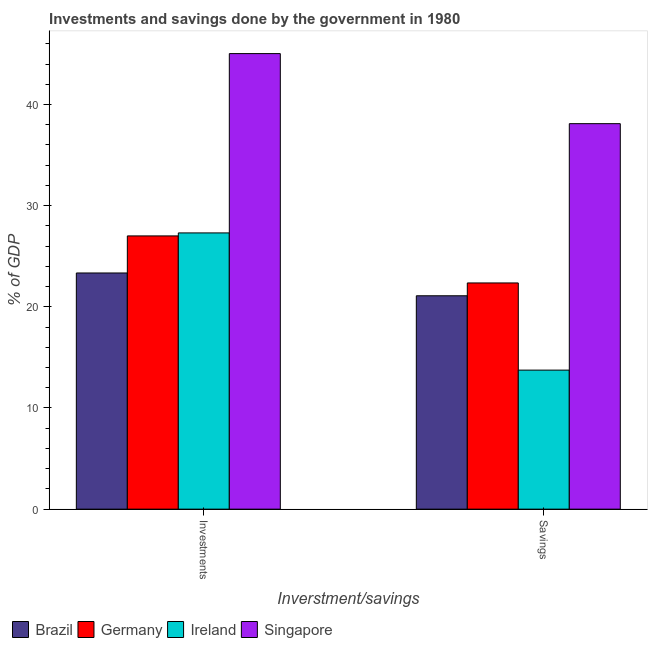How many groups of bars are there?
Offer a terse response. 2. Are the number of bars per tick equal to the number of legend labels?
Make the answer very short. Yes. How many bars are there on the 2nd tick from the left?
Provide a succinct answer. 4. What is the label of the 2nd group of bars from the left?
Offer a very short reply. Savings. What is the investments of government in Singapore?
Keep it short and to the point. 45.03. Across all countries, what is the maximum investments of government?
Your answer should be compact. 45.03. Across all countries, what is the minimum savings of government?
Keep it short and to the point. 13.74. In which country was the investments of government maximum?
Provide a short and direct response. Singapore. In which country was the savings of government minimum?
Offer a very short reply. Ireland. What is the total investments of government in the graph?
Provide a succinct answer. 122.7. What is the difference between the savings of government in Singapore and that in Germany?
Your answer should be very brief. 15.75. What is the difference between the investments of government in Brazil and the savings of government in Ireland?
Keep it short and to the point. 9.6. What is the average savings of government per country?
Make the answer very short. 23.83. What is the difference between the savings of government and investments of government in Singapore?
Provide a short and direct response. -6.93. What is the ratio of the savings of government in Singapore to that in Brazil?
Ensure brevity in your answer.  1.81. Is the investments of government in Brazil less than that in Singapore?
Your answer should be very brief. Yes. What does the 2nd bar from the left in Investments represents?
Your response must be concise. Germany. How many countries are there in the graph?
Offer a terse response. 4. What is the difference between two consecutive major ticks on the Y-axis?
Provide a succinct answer. 10. Where does the legend appear in the graph?
Keep it short and to the point. Bottom left. How many legend labels are there?
Ensure brevity in your answer.  4. What is the title of the graph?
Provide a succinct answer. Investments and savings done by the government in 1980. Does "Cyprus" appear as one of the legend labels in the graph?
Offer a terse response. No. What is the label or title of the X-axis?
Ensure brevity in your answer.  Inverstment/savings. What is the label or title of the Y-axis?
Your answer should be compact. % of GDP. What is the % of GDP in Brazil in Investments?
Give a very brief answer. 23.35. What is the % of GDP of Germany in Investments?
Keep it short and to the point. 27.01. What is the % of GDP in Ireland in Investments?
Offer a very short reply. 27.31. What is the % of GDP in Singapore in Investments?
Your answer should be very brief. 45.03. What is the % of GDP in Brazil in Savings?
Your response must be concise. 21.09. What is the % of GDP of Germany in Savings?
Your answer should be very brief. 22.36. What is the % of GDP in Ireland in Savings?
Your answer should be very brief. 13.74. What is the % of GDP in Singapore in Savings?
Offer a very short reply. 38.11. Across all Inverstment/savings, what is the maximum % of GDP in Brazil?
Your answer should be compact. 23.35. Across all Inverstment/savings, what is the maximum % of GDP in Germany?
Give a very brief answer. 27.01. Across all Inverstment/savings, what is the maximum % of GDP in Ireland?
Offer a very short reply. 27.31. Across all Inverstment/savings, what is the maximum % of GDP of Singapore?
Ensure brevity in your answer.  45.03. Across all Inverstment/savings, what is the minimum % of GDP of Brazil?
Your answer should be very brief. 21.09. Across all Inverstment/savings, what is the minimum % of GDP in Germany?
Give a very brief answer. 22.36. Across all Inverstment/savings, what is the minimum % of GDP in Ireland?
Offer a terse response. 13.74. Across all Inverstment/savings, what is the minimum % of GDP of Singapore?
Offer a terse response. 38.11. What is the total % of GDP of Brazil in the graph?
Your answer should be compact. 44.44. What is the total % of GDP in Germany in the graph?
Ensure brevity in your answer.  49.37. What is the total % of GDP in Ireland in the graph?
Your answer should be very brief. 41.05. What is the total % of GDP of Singapore in the graph?
Your answer should be compact. 83.14. What is the difference between the % of GDP of Brazil in Investments and that in Savings?
Offer a terse response. 2.25. What is the difference between the % of GDP of Germany in Investments and that in Savings?
Offer a terse response. 4.65. What is the difference between the % of GDP of Ireland in Investments and that in Savings?
Offer a very short reply. 13.56. What is the difference between the % of GDP in Singapore in Investments and that in Savings?
Your answer should be very brief. 6.93. What is the difference between the % of GDP of Brazil in Investments and the % of GDP of Germany in Savings?
Offer a very short reply. 0.98. What is the difference between the % of GDP of Brazil in Investments and the % of GDP of Ireland in Savings?
Your answer should be very brief. 9.6. What is the difference between the % of GDP of Brazil in Investments and the % of GDP of Singapore in Savings?
Your answer should be compact. -14.76. What is the difference between the % of GDP of Germany in Investments and the % of GDP of Ireland in Savings?
Your answer should be very brief. 13.27. What is the difference between the % of GDP in Germany in Investments and the % of GDP in Singapore in Savings?
Offer a terse response. -11.1. What is the difference between the % of GDP of Ireland in Investments and the % of GDP of Singapore in Savings?
Offer a terse response. -10.8. What is the average % of GDP of Brazil per Inverstment/savings?
Offer a very short reply. 22.22. What is the average % of GDP in Germany per Inverstment/savings?
Provide a succinct answer. 24.69. What is the average % of GDP of Ireland per Inverstment/savings?
Ensure brevity in your answer.  20.53. What is the average % of GDP in Singapore per Inverstment/savings?
Offer a very short reply. 41.57. What is the difference between the % of GDP in Brazil and % of GDP in Germany in Investments?
Make the answer very short. -3.66. What is the difference between the % of GDP of Brazil and % of GDP of Ireland in Investments?
Your answer should be compact. -3.96. What is the difference between the % of GDP of Brazil and % of GDP of Singapore in Investments?
Give a very brief answer. -21.69. What is the difference between the % of GDP in Germany and % of GDP in Ireland in Investments?
Offer a very short reply. -0.3. What is the difference between the % of GDP of Germany and % of GDP of Singapore in Investments?
Provide a succinct answer. -18.02. What is the difference between the % of GDP of Ireland and % of GDP of Singapore in Investments?
Provide a succinct answer. -17.73. What is the difference between the % of GDP in Brazil and % of GDP in Germany in Savings?
Offer a terse response. -1.27. What is the difference between the % of GDP in Brazil and % of GDP in Ireland in Savings?
Offer a terse response. 7.35. What is the difference between the % of GDP of Brazil and % of GDP of Singapore in Savings?
Offer a terse response. -17.01. What is the difference between the % of GDP in Germany and % of GDP in Ireland in Savings?
Ensure brevity in your answer.  8.62. What is the difference between the % of GDP in Germany and % of GDP in Singapore in Savings?
Keep it short and to the point. -15.75. What is the difference between the % of GDP of Ireland and % of GDP of Singapore in Savings?
Give a very brief answer. -24.36. What is the ratio of the % of GDP of Brazil in Investments to that in Savings?
Your answer should be very brief. 1.11. What is the ratio of the % of GDP of Germany in Investments to that in Savings?
Give a very brief answer. 1.21. What is the ratio of the % of GDP in Ireland in Investments to that in Savings?
Your response must be concise. 1.99. What is the ratio of the % of GDP of Singapore in Investments to that in Savings?
Make the answer very short. 1.18. What is the difference between the highest and the second highest % of GDP in Brazil?
Provide a short and direct response. 2.25. What is the difference between the highest and the second highest % of GDP in Germany?
Provide a succinct answer. 4.65. What is the difference between the highest and the second highest % of GDP in Ireland?
Give a very brief answer. 13.56. What is the difference between the highest and the second highest % of GDP in Singapore?
Offer a terse response. 6.93. What is the difference between the highest and the lowest % of GDP in Brazil?
Give a very brief answer. 2.25. What is the difference between the highest and the lowest % of GDP of Germany?
Offer a terse response. 4.65. What is the difference between the highest and the lowest % of GDP in Ireland?
Your answer should be compact. 13.56. What is the difference between the highest and the lowest % of GDP in Singapore?
Offer a very short reply. 6.93. 